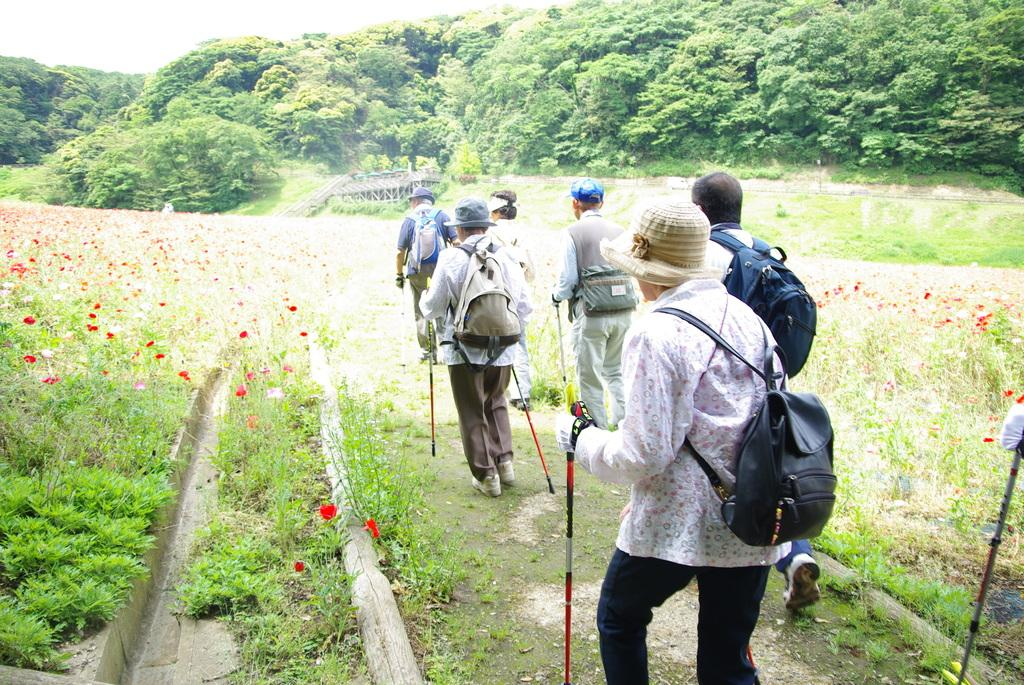What is happening in the image involving a group of people? There is a group of people in the image, and they are carrying bags and holding sticks in their hands. What might the people be doing with the sticks they are holding? It is not explicitly stated, but they could be using the sticks for support, protection, or as part of an activity. What is the surface on which the people are walking? The people are walking on the ground. What type of vegetation can be seen in the image? Flowers are visible in the image, and there are trees in the background. What type of yam is being used as a scarf by the monkey in the image? There is no monkey or yam present in the image. The image features a group of people carrying bags and holding sticks, walking on the ground, with flowers and trees in the background. 